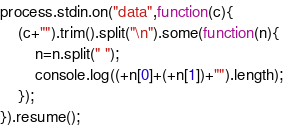<code> <loc_0><loc_0><loc_500><loc_500><_JavaScript_>process.stdin.on("data",function(c){
	(c+"").trim().split("\n").some(function(n){
		n=n.split(" ");
		console.log((+n[0]+(+n[1])+"").length);
	});
}).resume();</code> 